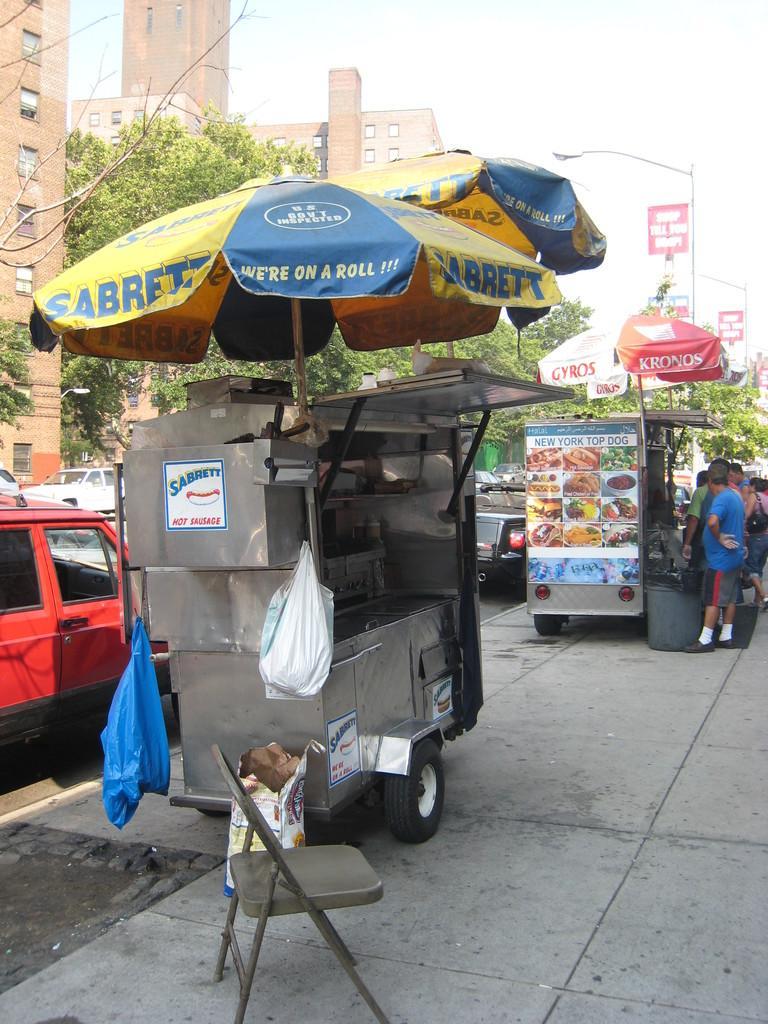Please provide a concise description of this image. In this image there is a footpath, on that footpath there is a chair and stalls and umbrellas people are standing on the footpath, beside the footpath there are cars on the road, in the background there are trees and buildings. 